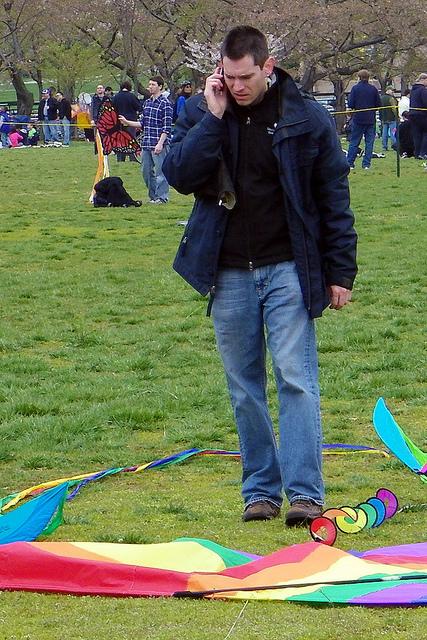Is it warm out?
Answer briefly. No. What is on the ground?
Quick response, please. Kite. Does the man look happy?
Write a very short answer. No. Is it a hot day?
Give a very brief answer. No. 